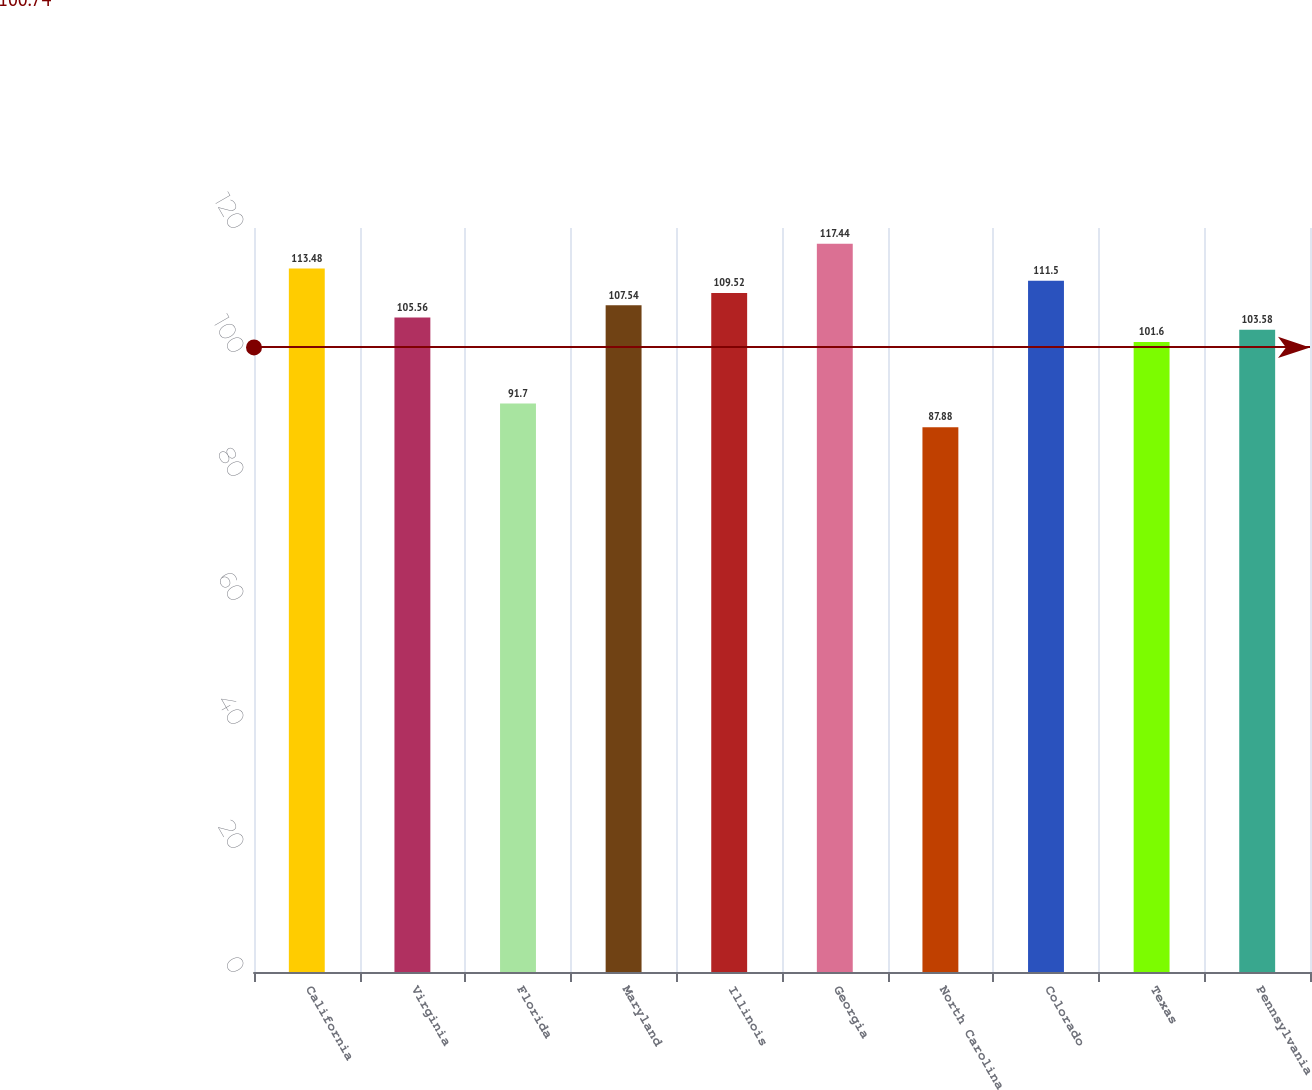Convert chart to OTSL. <chart><loc_0><loc_0><loc_500><loc_500><bar_chart><fcel>California<fcel>Virginia<fcel>Florida<fcel>Maryland<fcel>Illinois<fcel>Georgia<fcel>North Carolina<fcel>Colorado<fcel>Texas<fcel>Pennsylvania<nl><fcel>113.48<fcel>105.56<fcel>91.7<fcel>107.54<fcel>109.52<fcel>117.44<fcel>87.88<fcel>111.5<fcel>101.6<fcel>103.58<nl></chart> 